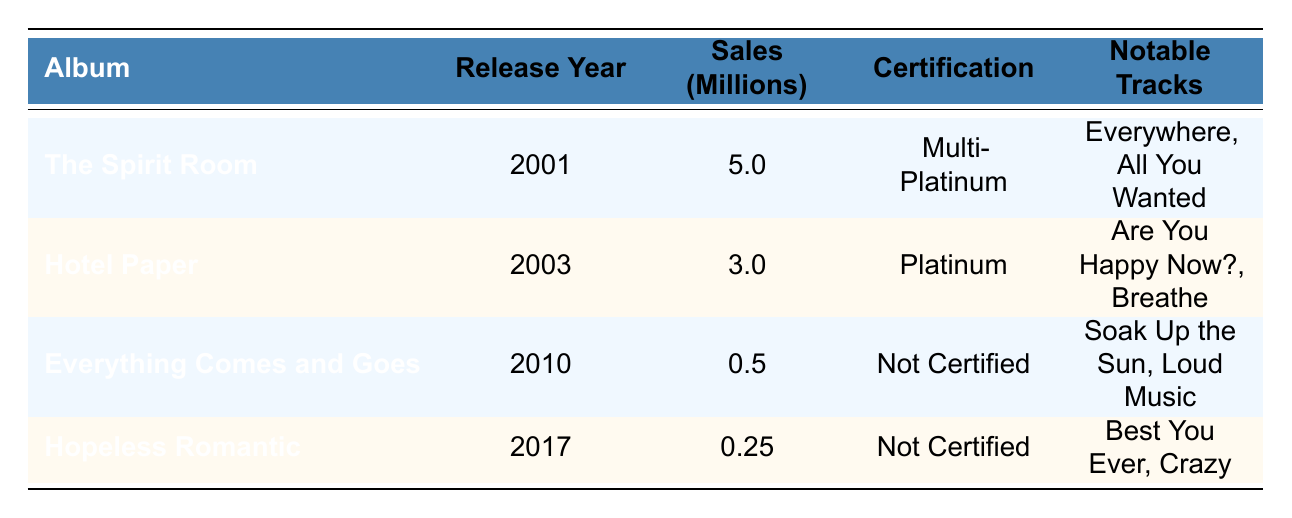What is the release year of "The Spirit Room"? The table lists "The Spirit Room" under the column for Album titles and indicates its release year as 2001.
Answer: 2001 Which album has the highest sales? By comparing the Sales in Millions column, "The Spirit Room" has the highest sales at 5.0 million compared to the other albums listed.
Answer: The Spirit Room How many albums were released after 2010? Looking at the Release Year column, the albums "Hopeless Romantic" (2017) and "Everything Comes and Goes" (2010) are the only ones released after 2010. Hence, there is one album released after 2010 when focusing on the criteria of strict "after" year.
Answer: 1 What is the total sales in millions for all albums? To find the total sales, sum the Sales in Millions for all albums: 5.0 (The Spirit Room) + 3.0 (Hotel Paper) + 0.5 (Everything Comes and Goes) + 0.25 (Hopeless Romantic) = 8.75 million.
Answer: 8.75 million Is "Hotel Paper" certified Platinum? The table states that "Hotel Paper" has a certification of Platinum, confirming that this statement is true.
Answer: Yes What is the average sales of all albums? There are four albums. The total sales is 8.75 million (calculated previously), so the average sales is 8.75 / 4 = 2.1875 million.
Answer: 2.1875 million Which album has the lowest sales, and what is its certification? Comparing the Sales in Millions, "Hopeless Romantic" has the lowest sales at 0.25 million and is categorized as Not Certified.
Answer: Hopeless Romantic, Not Certified Which album released in the 2000s sold less than 1 million copies? Looking at the table, both "Everything Comes and Goes" (2010) at 0.5 million and "Hopeless Romantic" (2017) at 0.25 million are less than 1 million; only the first one fits the criteria of being in the 2000s.
Answer: Everything Comes and Goes Did Michelle Branch release more albums in the 2000s or 2010s? Counting the albums, there are two released in the 2000s ("The Spirit Room" in 2001 and "Hotel Paper" in 2003) and one in the 2010s ("Everything Comes and Goes" in 2010) plus one more in 2017, which makes it a total of two in the 2010s. Since both decades have two albums, they are equal.
Answer: Equal 